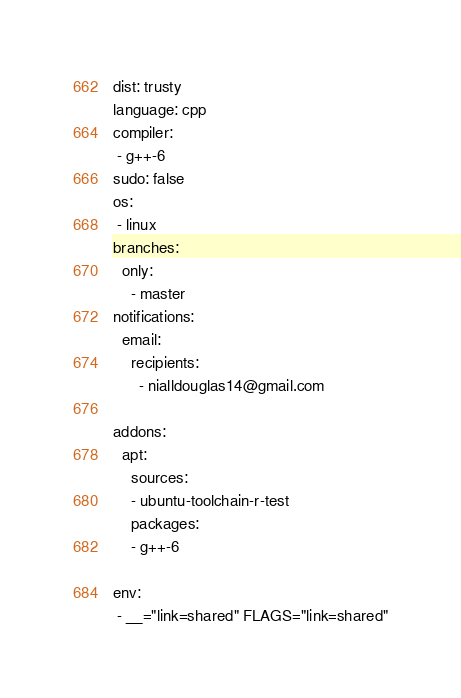<code> <loc_0><loc_0><loc_500><loc_500><_YAML_>dist: trusty
language: cpp
compiler:
 - g++-6
sudo: false
os:
 - linux
branches:
  only:
    - master
notifications:
  email:
    recipients:
      - nialldouglas14@gmail.com

addons:
  apt:
    sources:
    - ubuntu-toolchain-r-test
    packages:
    - g++-6

env:
 - __="link=shared" FLAGS="link=shared"</code> 